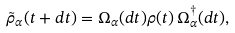Convert formula to latex. <formula><loc_0><loc_0><loc_500><loc_500>\tilde { \rho } _ { \alpha } ( t + d t ) = \Omega _ { \alpha } ( d t ) \rho ( t ) \, \Omega _ { \alpha } ^ { \dagger } ( d t ) ,</formula> 